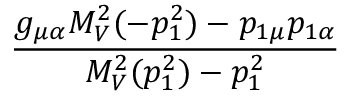<formula> <loc_0><loc_0><loc_500><loc_500>\frac { g _ { \mu \alpha } M _ { V } ^ { 2 } ( - p _ { 1 } ^ { 2 } ) - p _ { 1 \mu } p _ { 1 \alpha } } { M _ { V } ^ { 2 } ( p _ { 1 } ^ { 2 } ) - p _ { 1 } ^ { 2 } }</formula> 